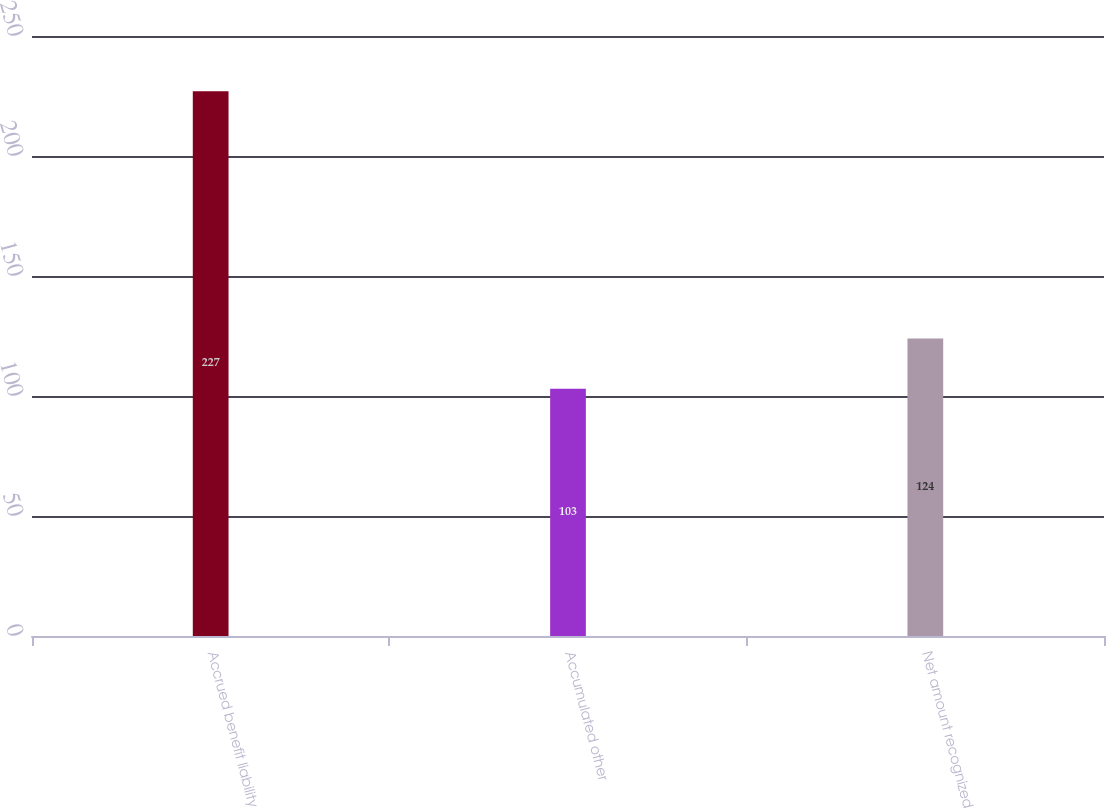<chart> <loc_0><loc_0><loc_500><loc_500><bar_chart><fcel>Accrued benefit liability<fcel>Accumulated other<fcel>Net amount recognized<nl><fcel>227<fcel>103<fcel>124<nl></chart> 